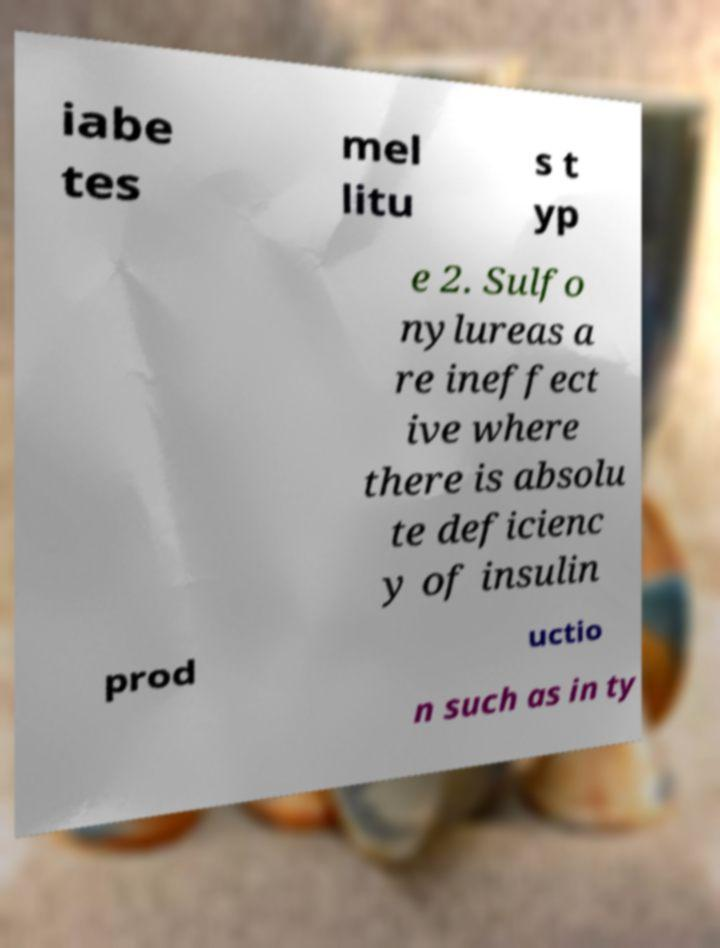Can you accurately transcribe the text from the provided image for me? iabe tes mel litu s t yp e 2. Sulfo nylureas a re ineffect ive where there is absolu te deficienc y of insulin prod uctio n such as in ty 